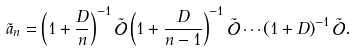<formula> <loc_0><loc_0><loc_500><loc_500>\tilde { a } _ { n } = \left ( 1 + \frac { D } { n } \right ) ^ { - 1 } \tilde { \mathcal { O } } \left ( 1 + \frac { D } { n - 1 } \right ) ^ { - 1 } \tilde { \mathcal { O } } \cdots \left ( 1 + D \right ) ^ { - 1 } \tilde { \mathcal { O } } .</formula> 